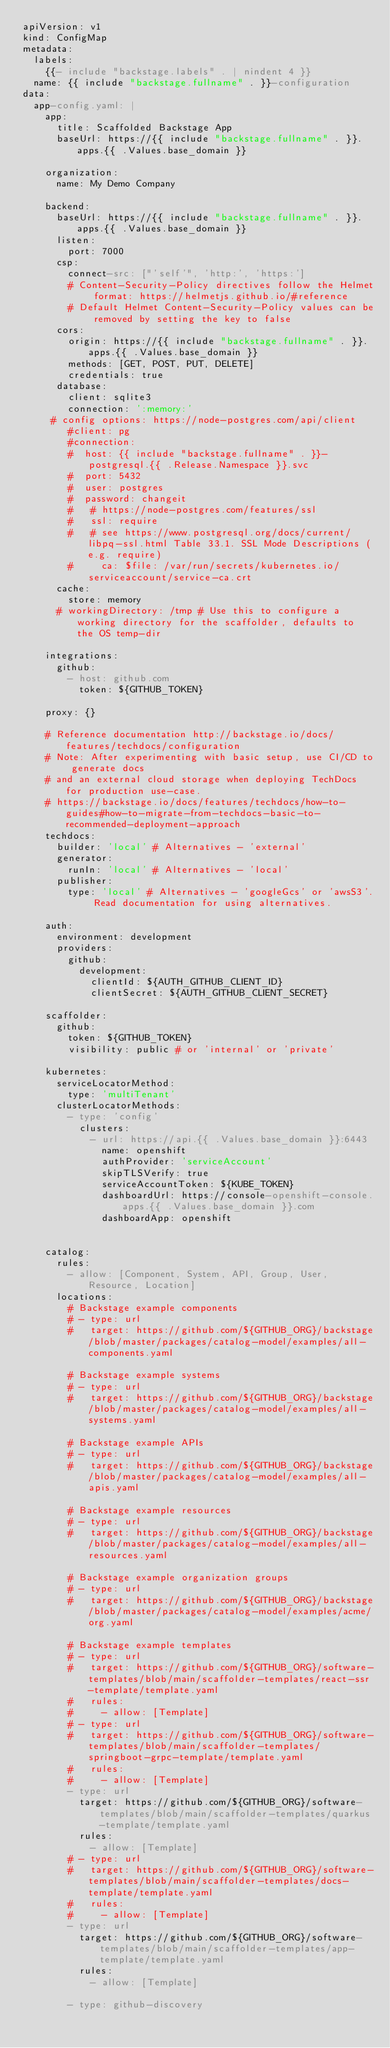<code> <loc_0><loc_0><loc_500><loc_500><_YAML_>apiVersion: v1
kind: ConfigMap
metadata:
  labels:
    {{- include "backstage.labels" . | nindent 4 }}
  name: {{ include "backstage.fullname" . }}-configuration
data:
  app-config.yaml: |
    app:
      title: Scaffolded Backstage App
      baseUrl: https://{{ include "backstage.fullname" . }}.apps.{{ .Values.base_domain }}

    organization:
      name: My Demo Company

    backend:
      baseUrl: https://{{ include "backstage.fullname" . }}.apps.{{ .Values.base_domain }}
      listen:
        port: 7000
      csp:
        connect-src: ["'self'", 'http:', 'https:']
        # Content-Security-Policy directives follow the Helmet format: https://helmetjs.github.io/#reference
        # Default Helmet Content-Security-Policy values can be removed by setting the key to false
      cors:
        origin: https://{{ include "backstage.fullname" . }}.apps.{{ .Values.base_domain }}
        methods: [GET, POST, PUT, DELETE]
        credentials: true
      database:
        client: sqlite3
        connection: ':memory:'
     # config options: https://node-postgres.com/api/client
        #client: pg
        #connection:
        #  host: {{ include "backstage.fullname" . }}-postgresql.{{ .Release.Namespace }}.svc
        #  port: 5432
        #  user: postgres
        #  password: changeit
        #   # https://node-postgres.com/features/ssl
        #   ssl: require 
        #   # see https://www.postgresql.org/docs/current/libpq-ssl.html Table 33.1. SSL Mode Descriptions (e.g. require)
        #     ca: $file: /var/run/secrets/kubernetes.io/serviceaccount/service-ca.crt
      cache:
        store: memory
      # workingDirectory: /tmp # Use this to configure a working directory for the scaffolder, defaults to the OS temp-dir

    integrations:
      github:
        - host: github.com
          token: ${GITHUB_TOKEN}

    proxy: {}

    # Reference documentation http://backstage.io/docs/features/techdocs/configuration
    # Note: After experimenting with basic setup, use CI/CD to generate docs
    # and an external cloud storage when deploying TechDocs for production use-case.
    # https://backstage.io/docs/features/techdocs/how-to-guides#how-to-migrate-from-techdocs-basic-to-recommended-deployment-approach
    techdocs:
      builder: 'local' # Alternatives - 'external'
      generator:
        runIn: 'local' # Alternatives - 'local'
      publisher:
        type: 'local' # Alternatives - 'googleGcs' or 'awsS3'. Read documentation for using alternatives.

    auth:
      environment: development
      providers:
        github:
          development:
            clientId: ${AUTH_GITHUB_CLIENT_ID}
            clientSecret: ${AUTH_GITHUB_CLIENT_SECRET}

    scaffolder:
      github:
        token: ${GITHUB_TOKEN}
        visibility: public # or 'internal' or 'private'

    kubernetes:
      serviceLocatorMethod:
        type: 'multiTenant'
      clusterLocatorMethods:
        - type: 'config'
          clusters:
            - url: https://api.{{ .Values.base_domain }}:6443
              name: openshift
              authProvider: 'serviceAccount'
              skipTLSVerify: true
              serviceAccountToken: ${KUBE_TOKEN}
              dashboardUrl: https://console-openshift-console.apps.{{ .Values.base_domain }}.com
              dashboardApp: openshift


    catalog:
      rules:
        - allow: [Component, System, API, Group, User, Resource, Location]
      locations:
        # Backstage example components
        # - type: url
        #   target: https://github.com/${GITHUB_ORG}/backstage/blob/master/packages/catalog-model/examples/all-components.yaml

        # Backstage example systems
        # - type: url
        #   target: https://github.com/${GITHUB_ORG}/backstage/blob/master/packages/catalog-model/examples/all-systems.yaml

        # Backstage example APIs
        # - type: url
        #   target: https://github.com/${GITHUB_ORG}/backstage/blob/master/packages/catalog-model/examples/all-apis.yaml

        # Backstage example resources
        # - type: url
        #   target: https://github.com/${GITHUB_ORG}/backstage/blob/master/packages/catalog-model/examples/all-resources.yaml

        # Backstage example organization groups
        # - type: url
        #   target: https://github.com/${GITHUB_ORG}/backstage/blob/master/packages/catalog-model/examples/acme/org.yaml

        # Backstage example templates
        # - type: url
        #   target: https://github.com/${GITHUB_ORG}/software-templates/blob/main/scaffolder-templates/react-ssr-template/template.yaml
        #   rules:
        #     - allow: [Template]
        # - type: url
        #   target: https://github.com/${GITHUB_ORG}/software-templates/blob/main/scaffolder-templates/springboot-grpc-template/template.yaml
        #   rules:
        #     - allow: [Template]
        - type: url
          target: https://github.com/${GITHUB_ORG}/software-templates/blob/main/scaffolder-templates/quarkus-template/template.yaml
          rules:
            - allow: [Template] 
        # - type: url
        #   target: https://github.com/${GITHUB_ORG}/software-templates/blob/main/scaffolder-templates/docs-template/template.yaml
        #   rules:
        #     - allow: [Template]
        - type: url
          target: https://github.com/${GITHUB_ORG}/software-templates/blob/main/scaffolder-templates/app-template/template.yaml
          rules:
            - allow: [Template]            

        - type: github-discovery</code> 